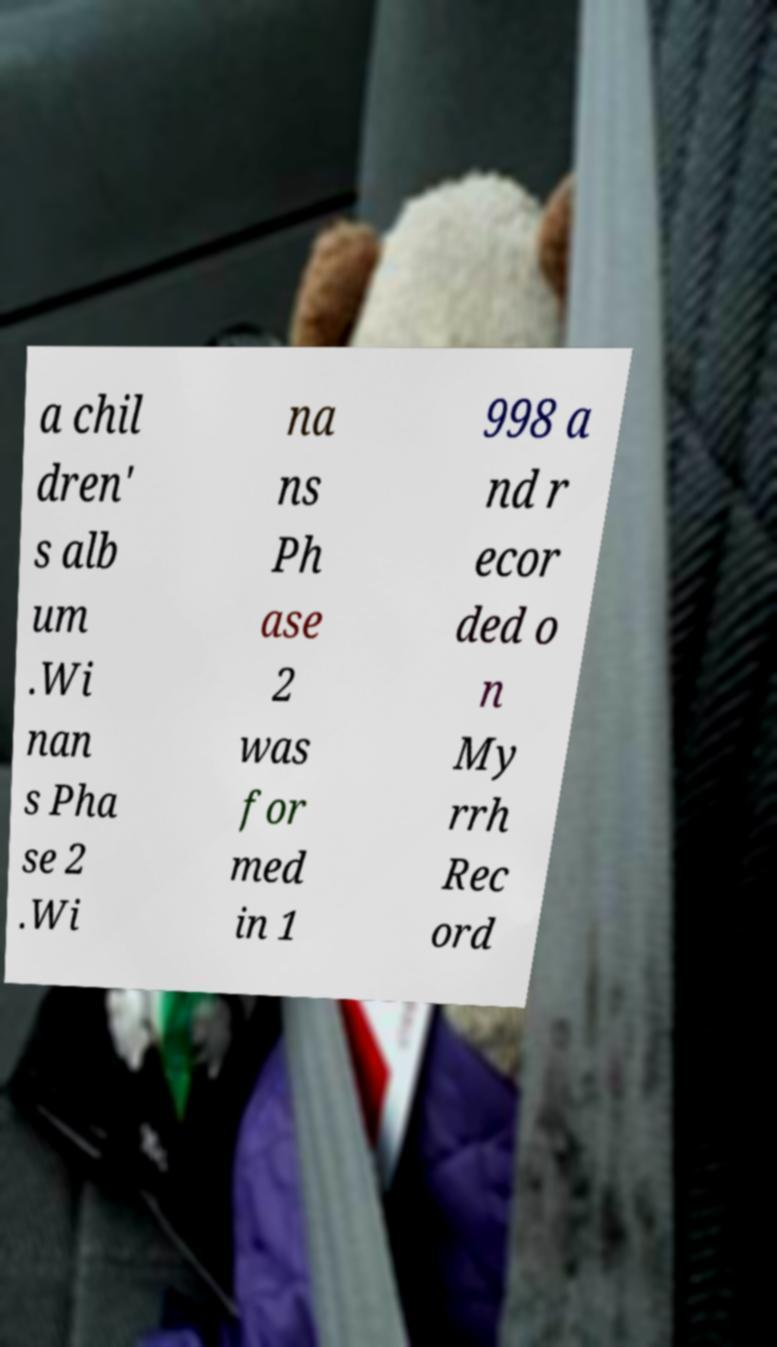I need the written content from this picture converted into text. Can you do that? a chil dren' s alb um .Wi nan s Pha se 2 .Wi na ns Ph ase 2 was for med in 1 998 a nd r ecor ded o n My rrh Rec ord 